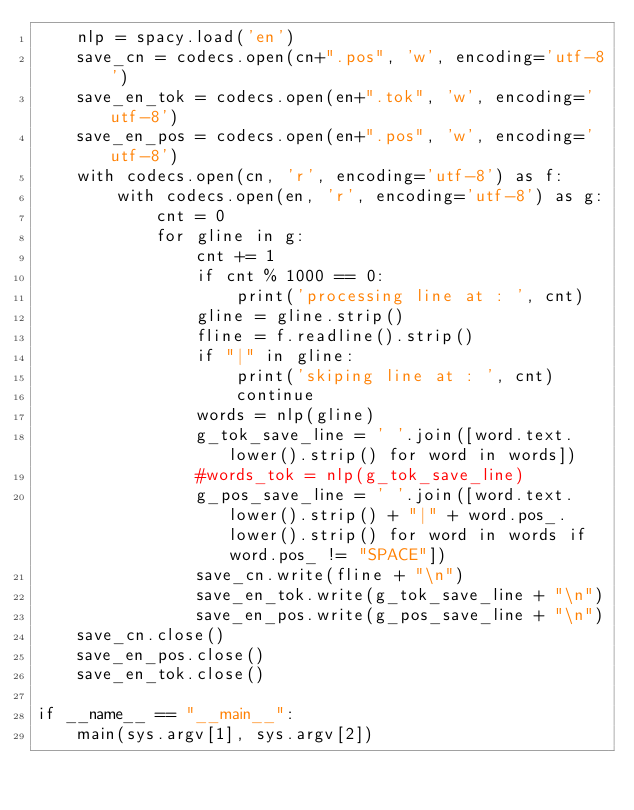Convert code to text. <code><loc_0><loc_0><loc_500><loc_500><_Python_>    nlp = spacy.load('en')
    save_cn = codecs.open(cn+".pos", 'w', encoding='utf-8')
    save_en_tok = codecs.open(en+".tok", 'w', encoding='utf-8')
    save_en_pos = codecs.open(en+".pos", 'w', encoding='utf-8')
    with codecs.open(cn, 'r', encoding='utf-8') as f:
        with codecs.open(en, 'r', encoding='utf-8') as g:
            cnt = 0
            for gline in g:
                cnt += 1
                if cnt % 1000 == 0:
                    print('processing line at : ', cnt)
                gline = gline.strip()
                fline = f.readline().strip()
                if "|" in gline:
                    print('skiping line at : ', cnt)
                    continue
                words = nlp(gline)
                g_tok_save_line = ' '.join([word.text.lower().strip() for word in words])
                #words_tok = nlp(g_tok_save_line)
                g_pos_save_line = ' '.join([word.text.lower().strip() + "|" + word.pos_.lower().strip() for word in words if word.pos_ != "SPACE"])
                save_cn.write(fline + "\n")
                save_en_tok.write(g_tok_save_line + "\n")
                save_en_pos.write(g_pos_save_line + "\n")
    save_cn.close()
    save_en_pos.close()
    save_en_tok.close()

if __name__ == "__main__":
    main(sys.argv[1], sys.argv[2])
</code> 